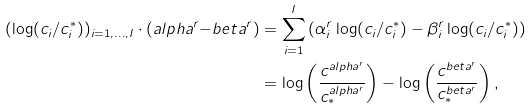Convert formula to latex. <formula><loc_0><loc_0><loc_500><loc_500>( \log ( c _ { i } / c ^ { * } _ { i } ) ) _ { i = 1 , \dots , I } \cdot \left ( a l p h a ^ { r } { - } b e t a ^ { r } \right ) & = \sum _ { i = 1 } ^ { I } \left ( \alpha _ { i } ^ { r } \log ( c _ { i } / c ^ { * } _ { i } ) - \beta _ { i } ^ { r } \log ( c _ { i } / c ^ { * } _ { i } ) \right ) \\ & = \log \left ( \frac { c ^ { a l p h a ^ { r } } } { c _ { * } ^ { a l p h a ^ { r } } } \right ) - \log \left ( \frac { c ^ { b e t a ^ { r } } } { c ^ { b e t a ^ { r } } _ { * } } \right ) ,</formula> 